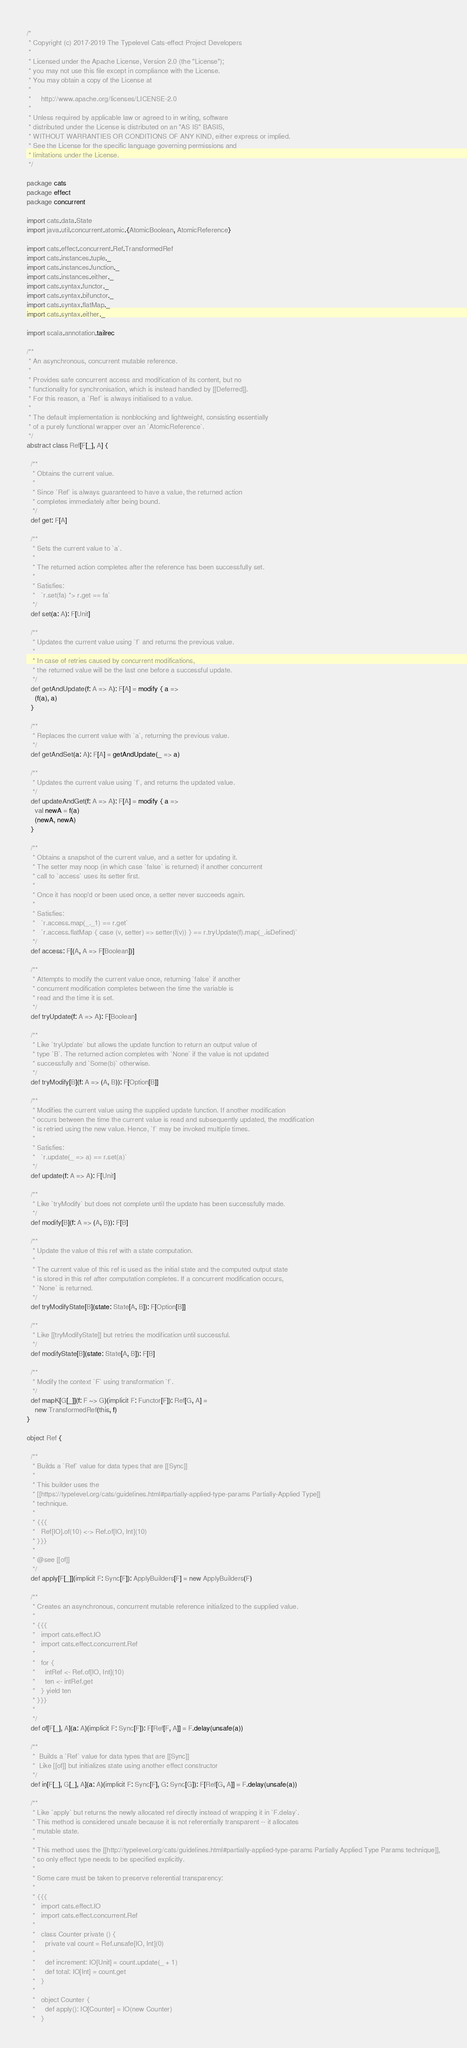<code> <loc_0><loc_0><loc_500><loc_500><_Scala_>/*
 * Copyright (c) 2017-2019 The Typelevel Cats-effect Project Developers
 *
 * Licensed under the Apache License, Version 2.0 (the "License");
 * you may not use this file except in compliance with the License.
 * You may obtain a copy of the License at
 *
 *     http://www.apache.org/licenses/LICENSE-2.0
 *
 * Unless required by applicable law or agreed to in writing, software
 * distributed under the License is distributed on an "AS IS" BASIS,
 * WITHOUT WARRANTIES OR CONDITIONS OF ANY KIND, either express or implied.
 * See the License for the specific language governing permissions and
 * limitations under the License.
 */

package cats
package effect
package concurrent

import cats.data.State
import java.util.concurrent.atomic.{AtomicBoolean, AtomicReference}

import cats.effect.concurrent.Ref.TransformedRef
import cats.instances.tuple._
import cats.instances.function._
import cats.instances.either._
import cats.syntax.functor._
import cats.syntax.bifunctor._
import cats.syntax.flatMap._
import cats.syntax.either._

import scala.annotation.tailrec

/**
 * An asynchronous, concurrent mutable reference.
 *
 * Provides safe concurrent access and modification of its content, but no
 * functionality for synchronisation, which is instead handled by [[Deferred]].
 * For this reason, a `Ref` is always initialised to a value.
 *
 * The default implementation is nonblocking and lightweight, consisting essentially
 * of a purely functional wrapper over an `AtomicReference`.
 */
abstract class Ref[F[_], A] {

  /**
   * Obtains the current value.
   *
   * Since `Ref` is always guaranteed to have a value, the returned action
   * completes immediately after being bound.
   */
  def get: F[A]

  /**
   * Sets the current value to `a`.
   *
   * The returned action completes after the reference has been successfully set.
   *
   * Satisfies:
   *   `r.set(fa) *> r.get == fa`
   */
  def set(a: A): F[Unit]

  /**
   * Updates the current value using `f` and returns the previous value.
   *
   * In case of retries caused by concurrent modifications,
   * the returned value will be the last one before a successful update.
   */
  def getAndUpdate(f: A => A): F[A] = modify { a =>
    (f(a), a)
  }

  /**
   * Replaces the current value with `a`, returning the previous value.
   */
  def getAndSet(a: A): F[A] = getAndUpdate(_ => a)

  /**
   * Updates the current value using `f`, and returns the updated value.
   */
  def updateAndGet(f: A => A): F[A] = modify { a =>
    val newA = f(a)
    (newA, newA)
  }

  /**
   * Obtains a snapshot of the current value, and a setter for updating it.
   * The setter may noop (in which case `false` is returned) if another concurrent
   * call to `access` uses its setter first.
   *
   * Once it has noop'd or been used once, a setter never succeeds again.
   *
   * Satisfies:
   *   `r.access.map(_._1) == r.get`
   *   `r.access.flatMap { case (v, setter) => setter(f(v)) } == r.tryUpdate(f).map(_.isDefined)`
   */
  def access: F[(A, A => F[Boolean])]

  /**
   * Attempts to modify the current value once, returning `false` if another
   * concurrent modification completes between the time the variable is
   * read and the time it is set.
   */
  def tryUpdate(f: A => A): F[Boolean]

  /**
   * Like `tryUpdate` but allows the update function to return an output value of
   * type `B`. The returned action completes with `None` if the value is not updated
   * successfully and `Some(b)` otherwise.
   */
  def tryModify[B](f: A => (A, B)): F[Option[B]]

  /**
   * Modifies the current value using the supplied update function. If another modification
   * occurs between the time the current value is read and subsequently updated, the modification
   * is retried using the new value. Hence, `f` may be invoked multiple times.
   *
   * Satisfies:
   *   `r.update(_ => a) == r.set(a)`
   */
  def update(f: A => A): F[Unit]

  /**
   * Like `tryModify` but does not complete until the update has been successfully made.
   */
  def modify[B](f: A => (A, B)): F[B]

  /**
   * Update the value of this ref with a state computation.
   *
   * The current value of this ref is used as the initial state and the computed output state
   * is stored in this ref after computation completes. If a concurrent modification occurs,
   * `None` is returned.
   */
  def tryModifyState[B](state: State[A, B]): F[Option[B]]

  /**
   * Like [[tryModifyState]] but retries the modification until successful.
   */
  def modifyState[B](state: State[A, B]): F[B]

  /**
   * Modify the context `F` using transformation `f`.
   */
  def mapK[G[_]](f: F ~> G)(implicit F: Functor[F]): Ref[G, A] =
    new TransformedRef(this, f)
}

object Ref {

  /**
   * Builds a `Ref` value for data types that are [[Sync]]
   *
   * This builder uses the
   * [[https://typelevel.org/cats/guidelines.html#partially-applied-type-params Partially-Applied Type]]
   * technique.
   *
   * {{{
   *   Ref[IO].of(10) <-> Ref.of[IO, Int](10)
   * }}}
   *
   * @see [[of]]
   */
  def apply[F[_]](implicit F: Sync[F]): ApplyBuilders[F] = new ApplyBuilders(F)

  /**
   * Creates an asynchronous, concurrent mutable reference initialized to the supplied value.
   *
   * {{{
   *   import cats.effect.IO
   *   import cats.effect.concurrent.Ref
   *
   *   for {
   *     intRef <- Ref.of[IO, Int](10)
   *     ten <- intRef.get
   *   } yield ten
   * }}}
   *
   */
  def of[F[_], A](a: A)(implicit F: Sync[F]): F[Ref[F, A]] = F.delay(unsafe(a))

  /**
   *  Builds a `Ref` value for data types that are [[Sync]]
   *  Like [[of]] but initializes state using another effect constructor
   */
  def in[F[_], G[_], A](a: A)(implicit F: Sync[F], G: Sync[G]): F[Ref[G, A]] = F.delay(unsafe(a))

  /**
   * Like `apply` but returns the newly allocated ref directly instead of wrapping it in `F.delay`.
   * This method is considered unsafe because it is not referentially transparent -- it allocates
   * mutable state.
   *
   * This method uses the [[http://typelevel.org/cats/guidelines.html#partially-applied-type-params Partially Applied Type Params technique]],
   * so only effect type needs to be specified explicitly.
   *
   * Some care must be taken to preserve referential transparency:
   *
   * {{{
   *   import cats.effect.IO
   *   import cats.effect.concurrent.Ref
   *
   *   class Counter private () {
   *     private val count = Ref.unsafe[IO, Int](0)
   *
   *     def increment: IO[Unit] = count.update(_ + 1)
   *     def total: IO[Int] = count.get
   *   }
   *
   *   object Counter {
   *     def apply(): IO[Counter] = IO(new Counter)
   *   }</code> 